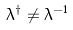Convert formula to latex. <formula><loc_0><loc_0><loc_500><loc_500>\lambda ^ { \dagger } \ne \lambda ^ { - 1 }</formula> 